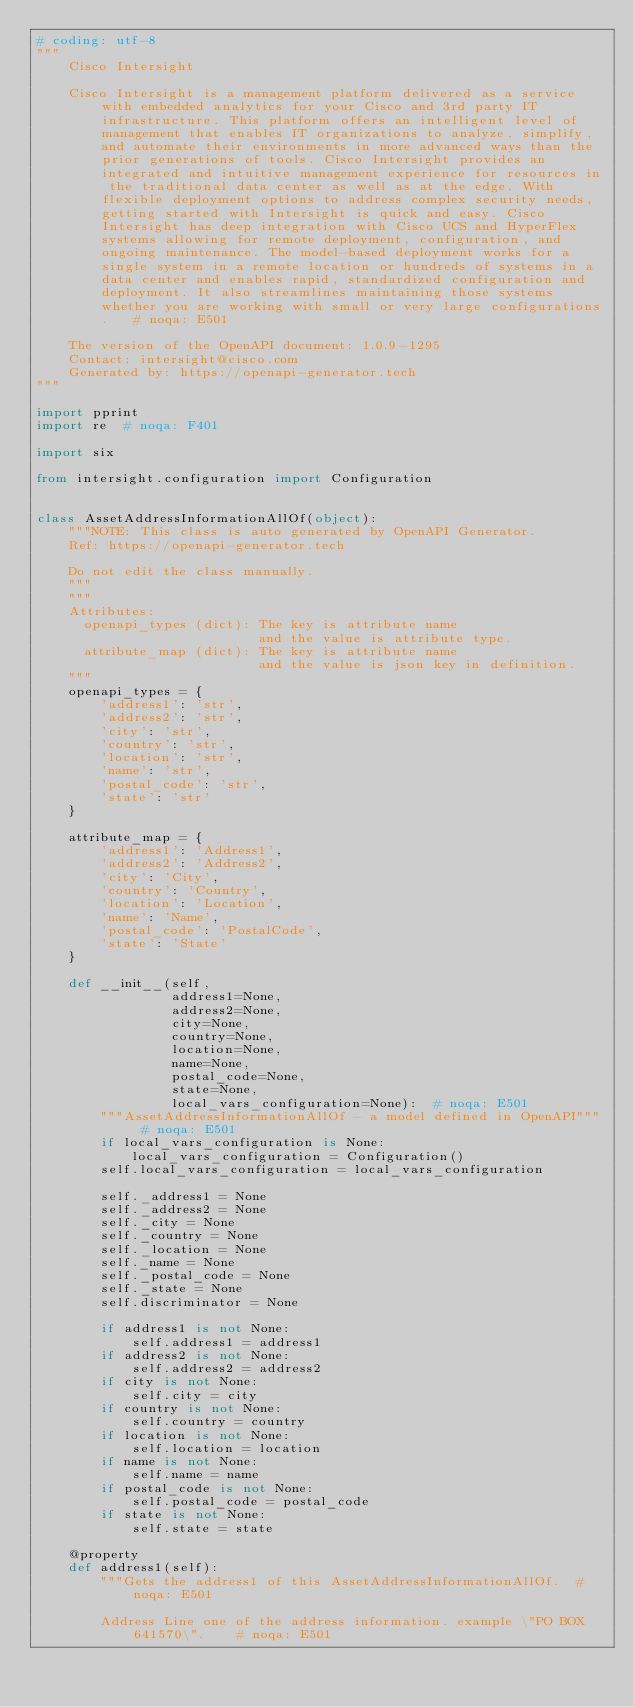<code> <loc_0><loc_0><loc_500><loc_500><_Python_># coding: utf-8
"""
    Cisco Intersight

    Cisco Intersight is a management platform delivered as a service with embedded analytics for your Cisco and 3rd party IT infrastructure. This platform offers an intelligent level of management that enables IT organizations to analyze, simplify, and automate their environments in more advanced ways than the prior generations of tools. Cisco Intersight provides an integrated and intuitive management experience for resources in the traditional data center as well as at the edge. With flexible deployment options to address complex security needs, getting started with Intersight is quick and easy. Cisco Intersight has deep integration with Cisco UCS and HyperFlex systems allowing for remote deployment, configuration, and ongoing maintenance. The model-based deployment works for a single system in a remote location or hundreds of systems in a data center and enables rapid, standardized configuration and deployment. It also streamlines maintaining those systems whether you are working with small or very large configurations.   # noqa: E501

    The version of the OpenAPI document: 1.0.9-1295
    Contact: intersight@cisco.com
    Generated by: https://openapi-generator.tech
"""

import pprint
import re  # noqa: F401

import six

from intersight.configuration import Configuration


class AssetAddressInformationAllOf(object):
    """NOTE: This class is auto generated by OpenAPI Generator.
    Ref: https://openapi-generator.tech

    Do not edit the class manually.
    """
    """
    Attributes:
      openapi_types (dict): The key is attribute name
                            and the value is attribute type.
      attribute_map (dict): The key is attribute name
                            and the value is json key in definition.
    """
    openapi_types = {
        'address1': 'str',
        'address2': 'str',
        'city': 'str',
        'country': 'str',
        'location': 'str',
        'name': 'str',
        'postal_code': 'str',
        'state': 'str'
    }

    attribute_map = {
        'address1': 'Address1',
        'address2': 'Address2',
        'city': 'City',
        'country': 'Country',
        'location': 'Location',
        'name': 'Name',
        'postal_code': 'PostalCode',
        'state': 'State'
    }

    def __init__(self,
                 address1=None,
                 address2=None,
                 city=None,
                 country=None,
                 location=None,
                 name=None,
                 postal_code=None,
                 state=None,
                 local_vars_configuration=None):  # noqa: E501
        """AssetAddressInformationAllOf - a model defined in OpenAPI"""  # noqa: E501
        if local_vars_configuration is None:
            local_vars_configuration = Configuration()
        self.local_vars_configuration = local_vars_configuration

        self._address1 = None
        self._address2 = None
        self._city = None
        self._country = None
        self._location = None
        self._name = None
        self._postal_code = None
        self._state = None
        self.discriminator = None

        if address1 is not None:
            self.address1 = address1
        if address2 is not None:
            self.address2 = address2
        if city is not None:
            self.city = city
        if country is not None:
            self.country = country
        if location is not None:
            self.location = location
        if name is not None:
            self.name = name
        if postal_code is not None:
            self.postal_code = postal_code
        if state is not None:
            self.state = state

    @property
    def address1(self):
        """Gets the address1 of this AssetAddressInformationAllOf.  # noqa: E501

        Address Line one of the address information. example \"PO BOX 641570\".    # noqa: E501
</code> 